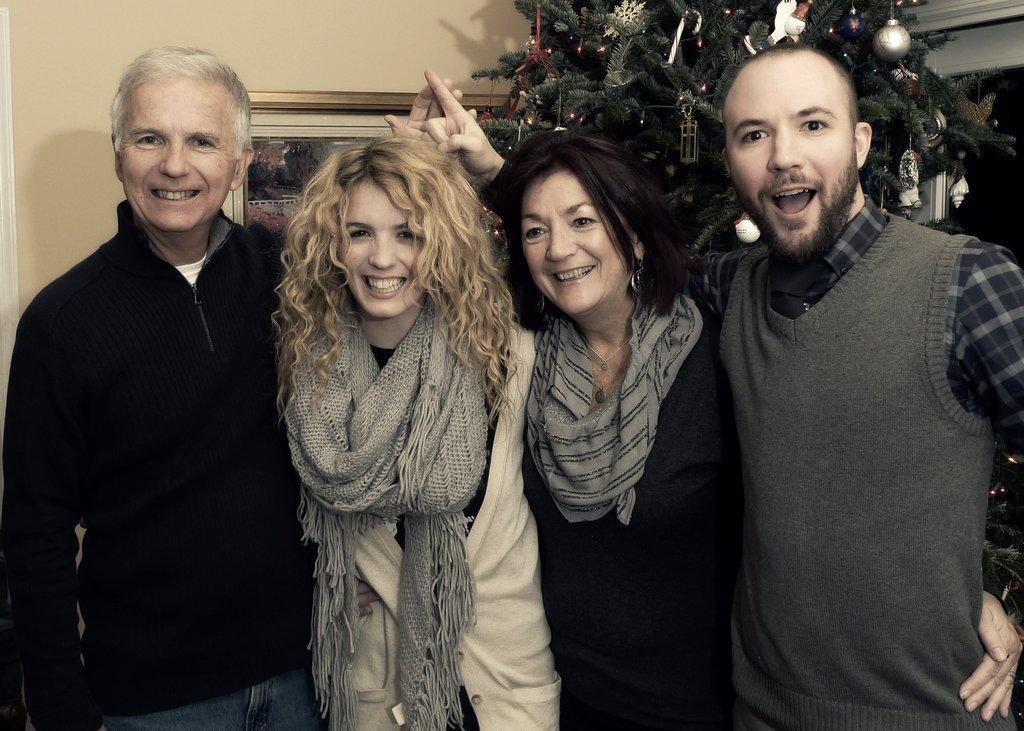How would you summarize this image in a sentence or two? In this image there are two women and two men standing, in the background there is a Christmas tree, wall to that wall there is a photo frame. 